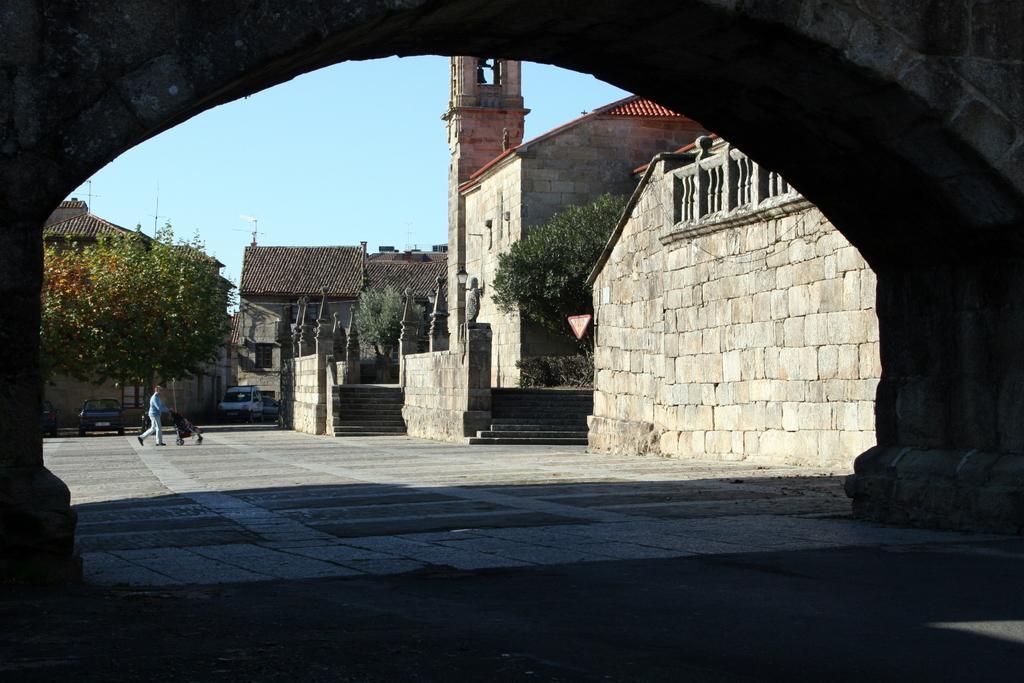Could you give a brief overview of what you see in this image? In the image there is an arch. Behind the arch there are building with walls, roofs and pillars. And also there are steps. There are few vehicles on the floor. There is a man walking and holding the stroller in his hand. And in the background there are trees and also there is sky with clouds. 